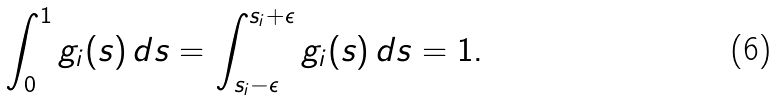Convert formula to latex. <formula><loc_0><loc_0><loc_500><loc_500>\int _ { 0 } ^ { 1 } g _ { i } ( s ) \, d s = \int _ { s _ { i } - \epsilon } ^ { s _ { i } + \epsilon } g _ { i } ( s ) \, d s = 1 .</formula> 